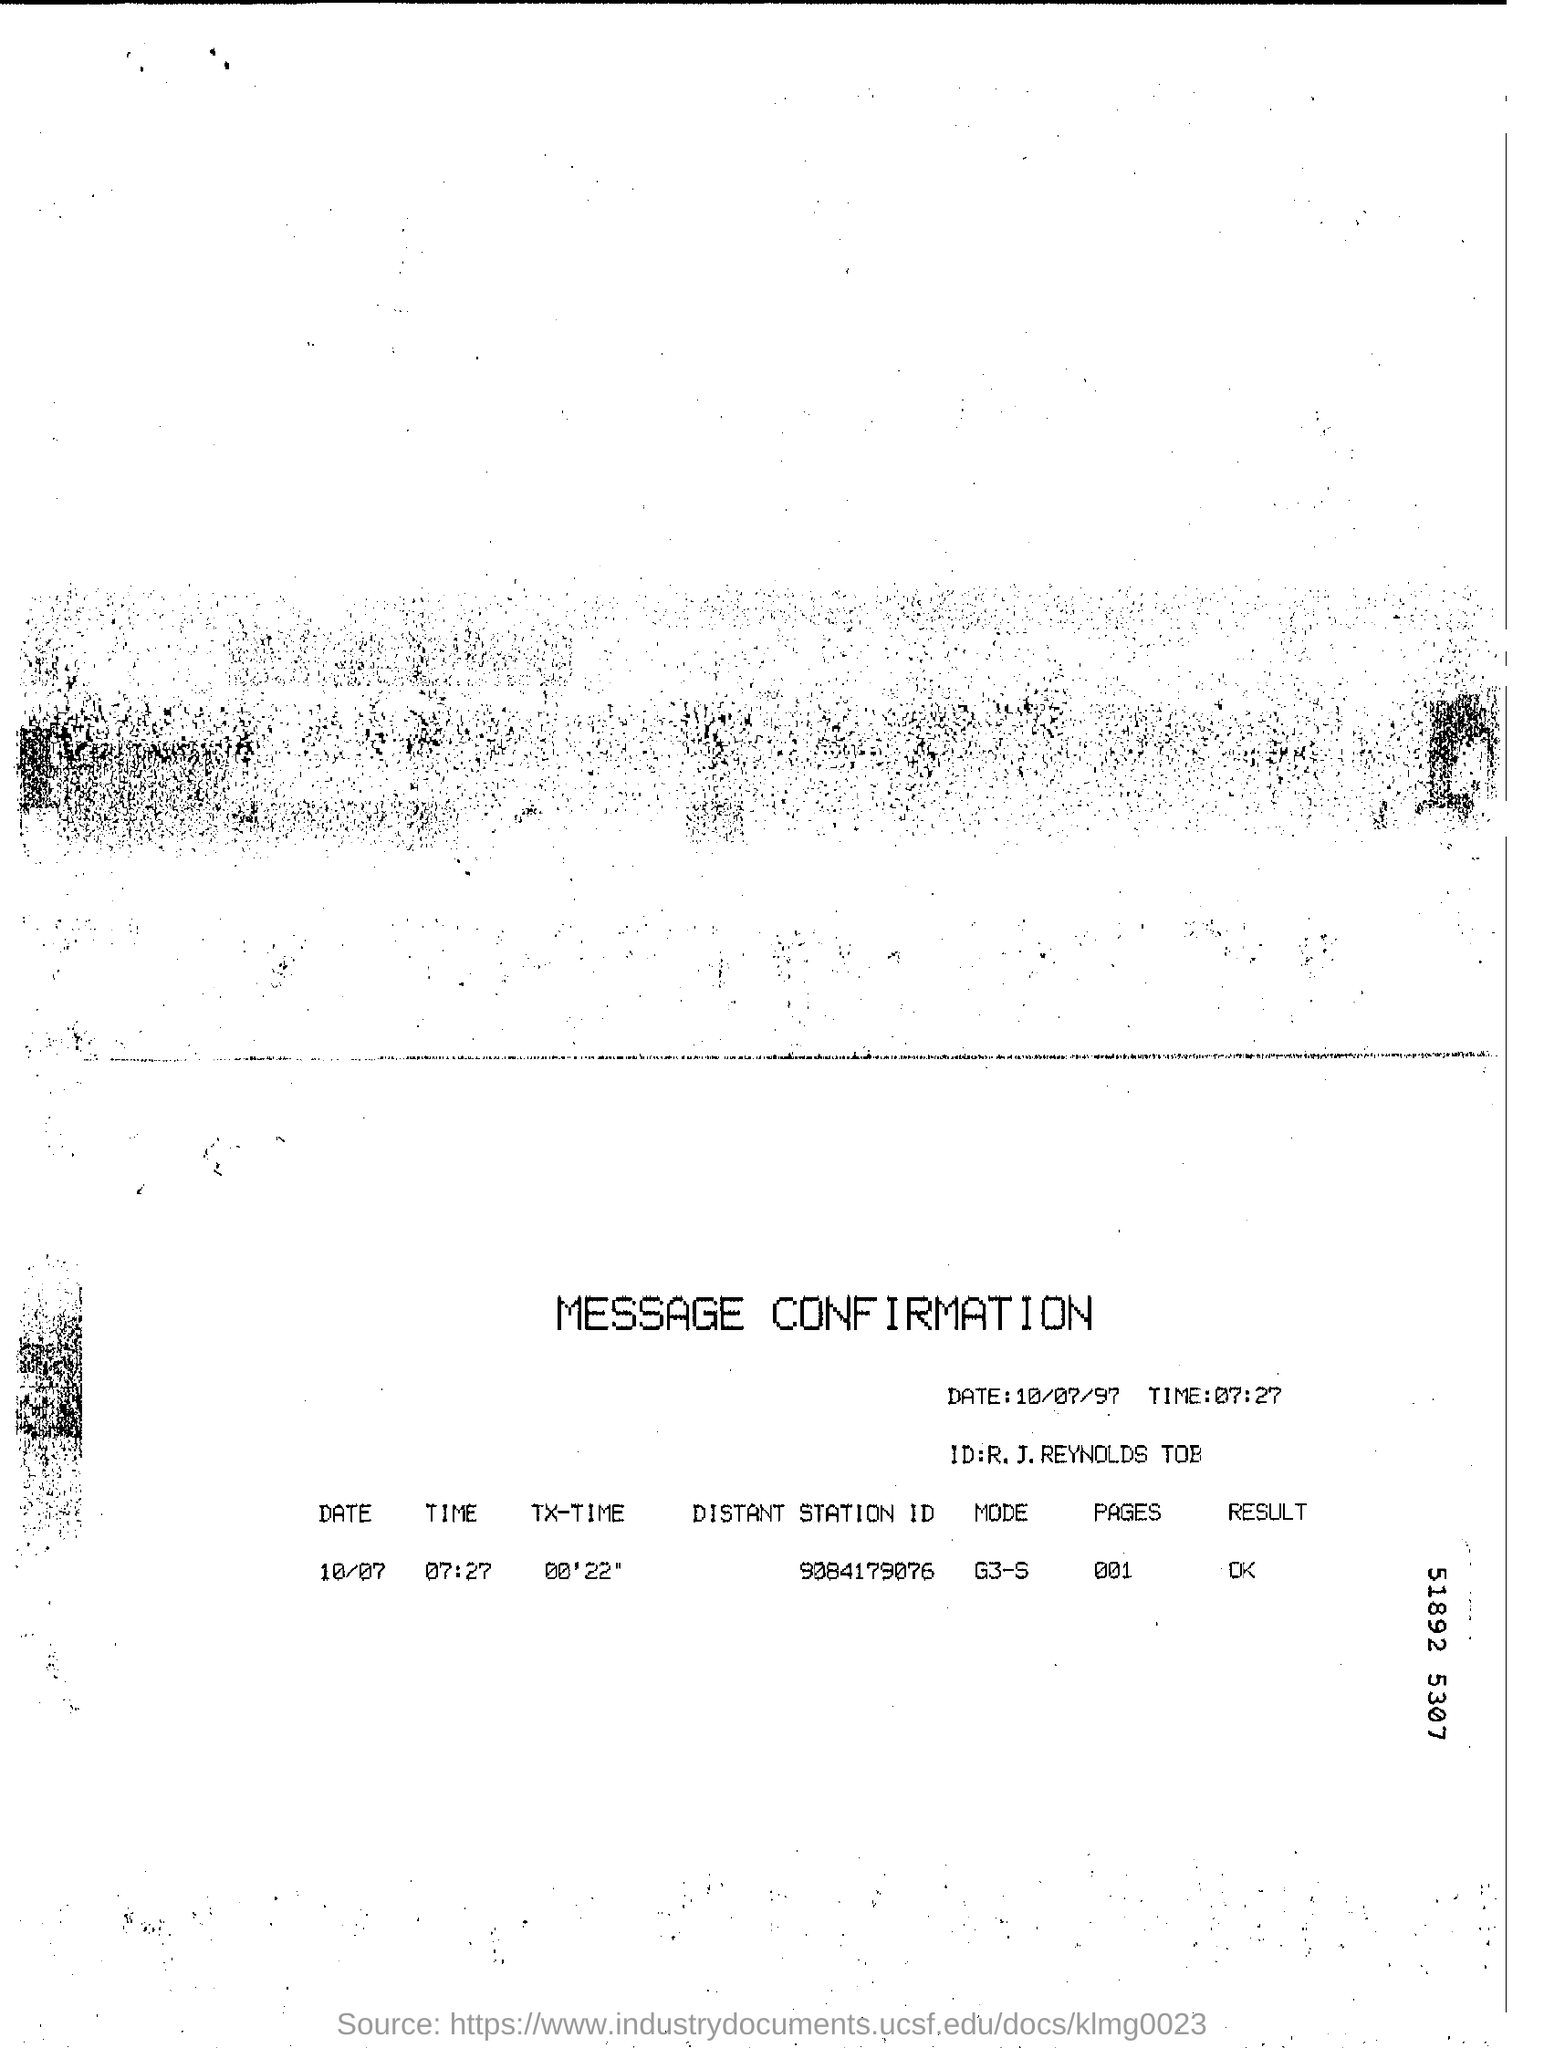What kind of document is this?
Keep it short and to the point. Message Confirmation. What is the Distant Station ID given in the document?
Ensure brevity in your answer.  9084179076. What is the date mentioned in this document?
Give a very brief answer. 10/07/97. What is the TX-TIME mentioned in the document?
Your answer should be compact. 00'22". 